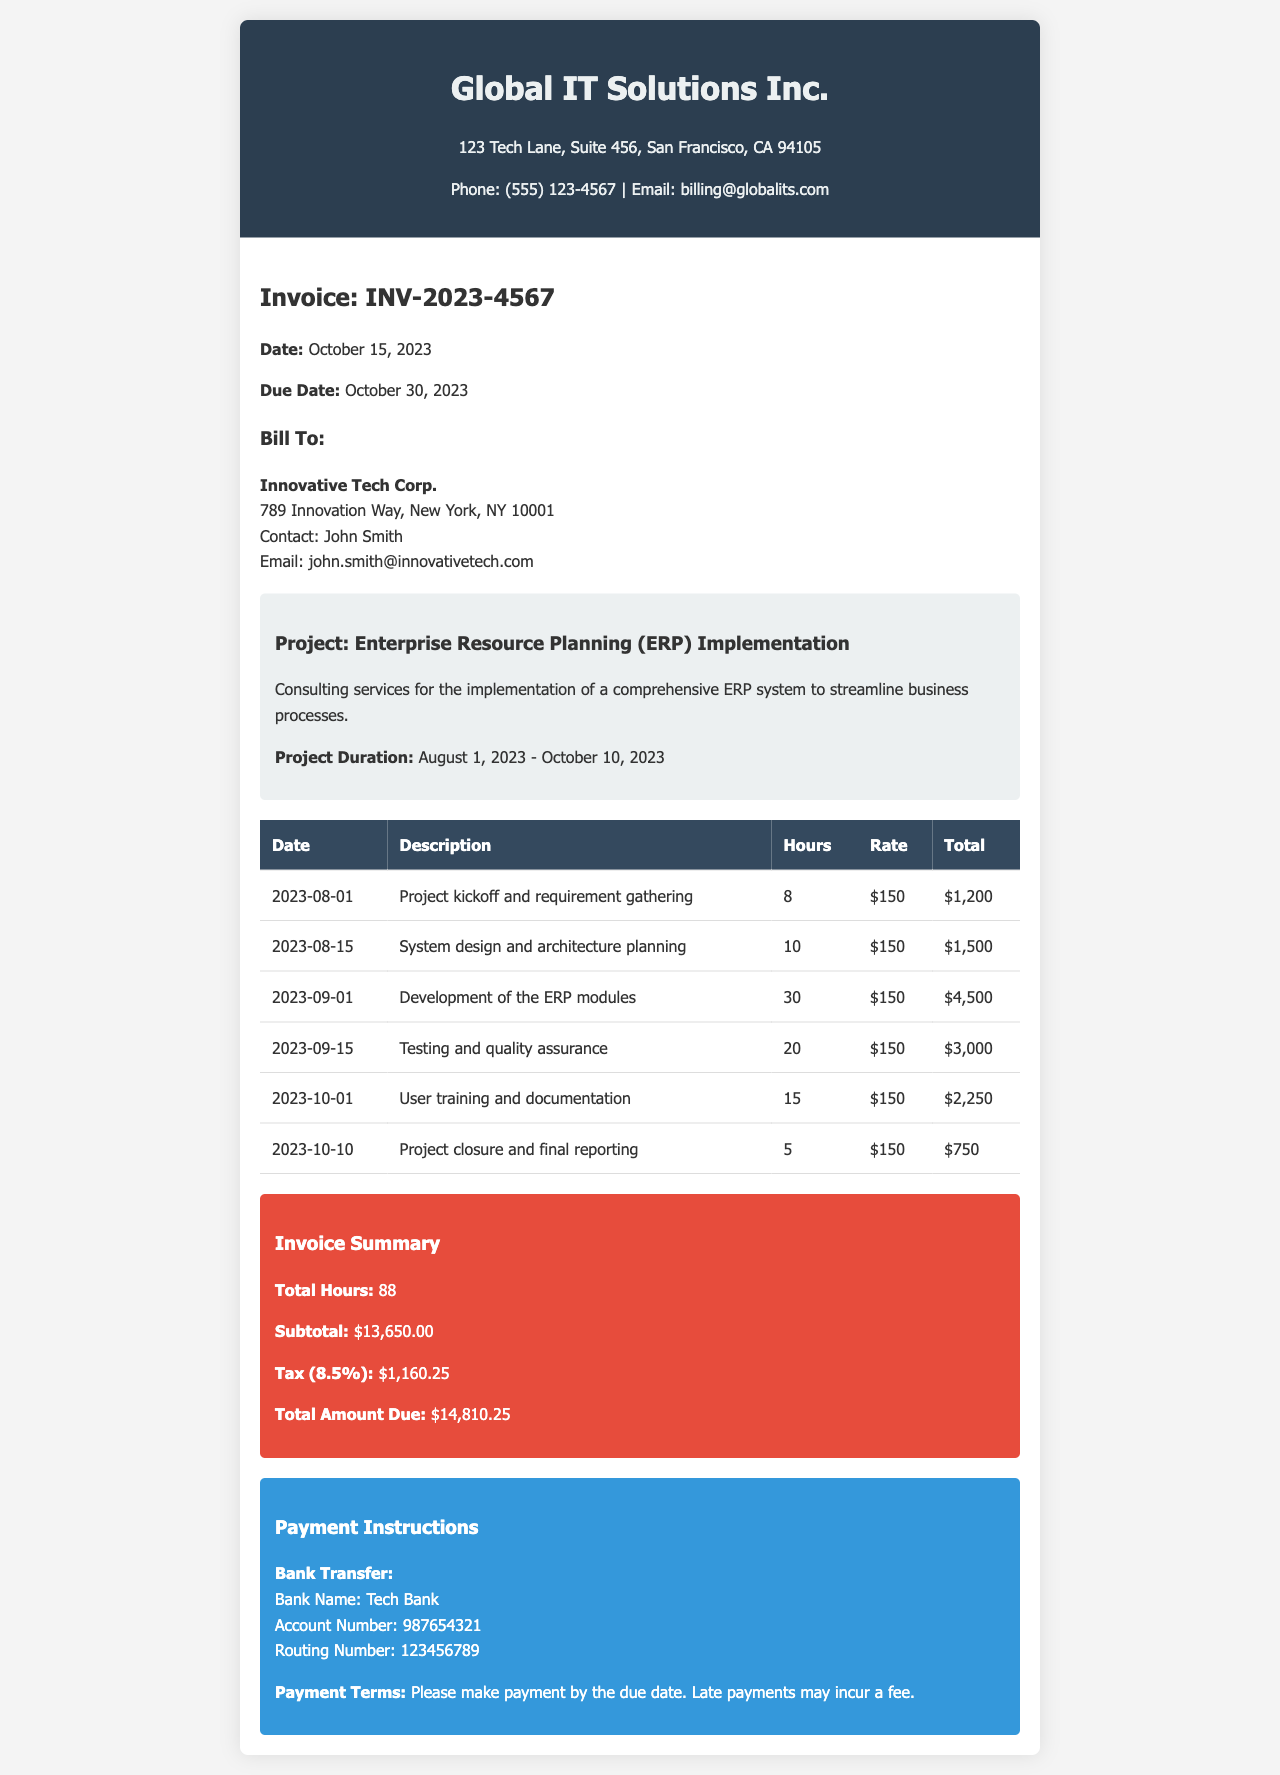What is the invoice number? The invoice number is provided under the company information section.
Answer: INV-2023-4567 Who is the client? The client details can be found in the client information section.
Answer: Innovative Tech Corp What is the total amount due? The total amount due is located in the summary section of the invoice.
Answer: $14,810.25 How many hours were worked in total? The total hours worked can be found in the summary section of the invoice.
Answer: 88 What is the hourly rate for the consulting services? The hourly rate is indicated in the table for each service provided.
Answer: $150 What was the date of the project kickoff? The project kickoff date is listed in the table of services rendered.
Answer: 2023-08-01 What is the tax rate applied? The tax rate can be found in the invoice summary section.
Answer: 8.5% What is the due date for payment? The due date is outlined in the company information section of the invoice.
Answer: October 30, 2023 What description is given for the last service listed? The description for the last service can be found in the table provided.
Answer: Project closure and final reporting 